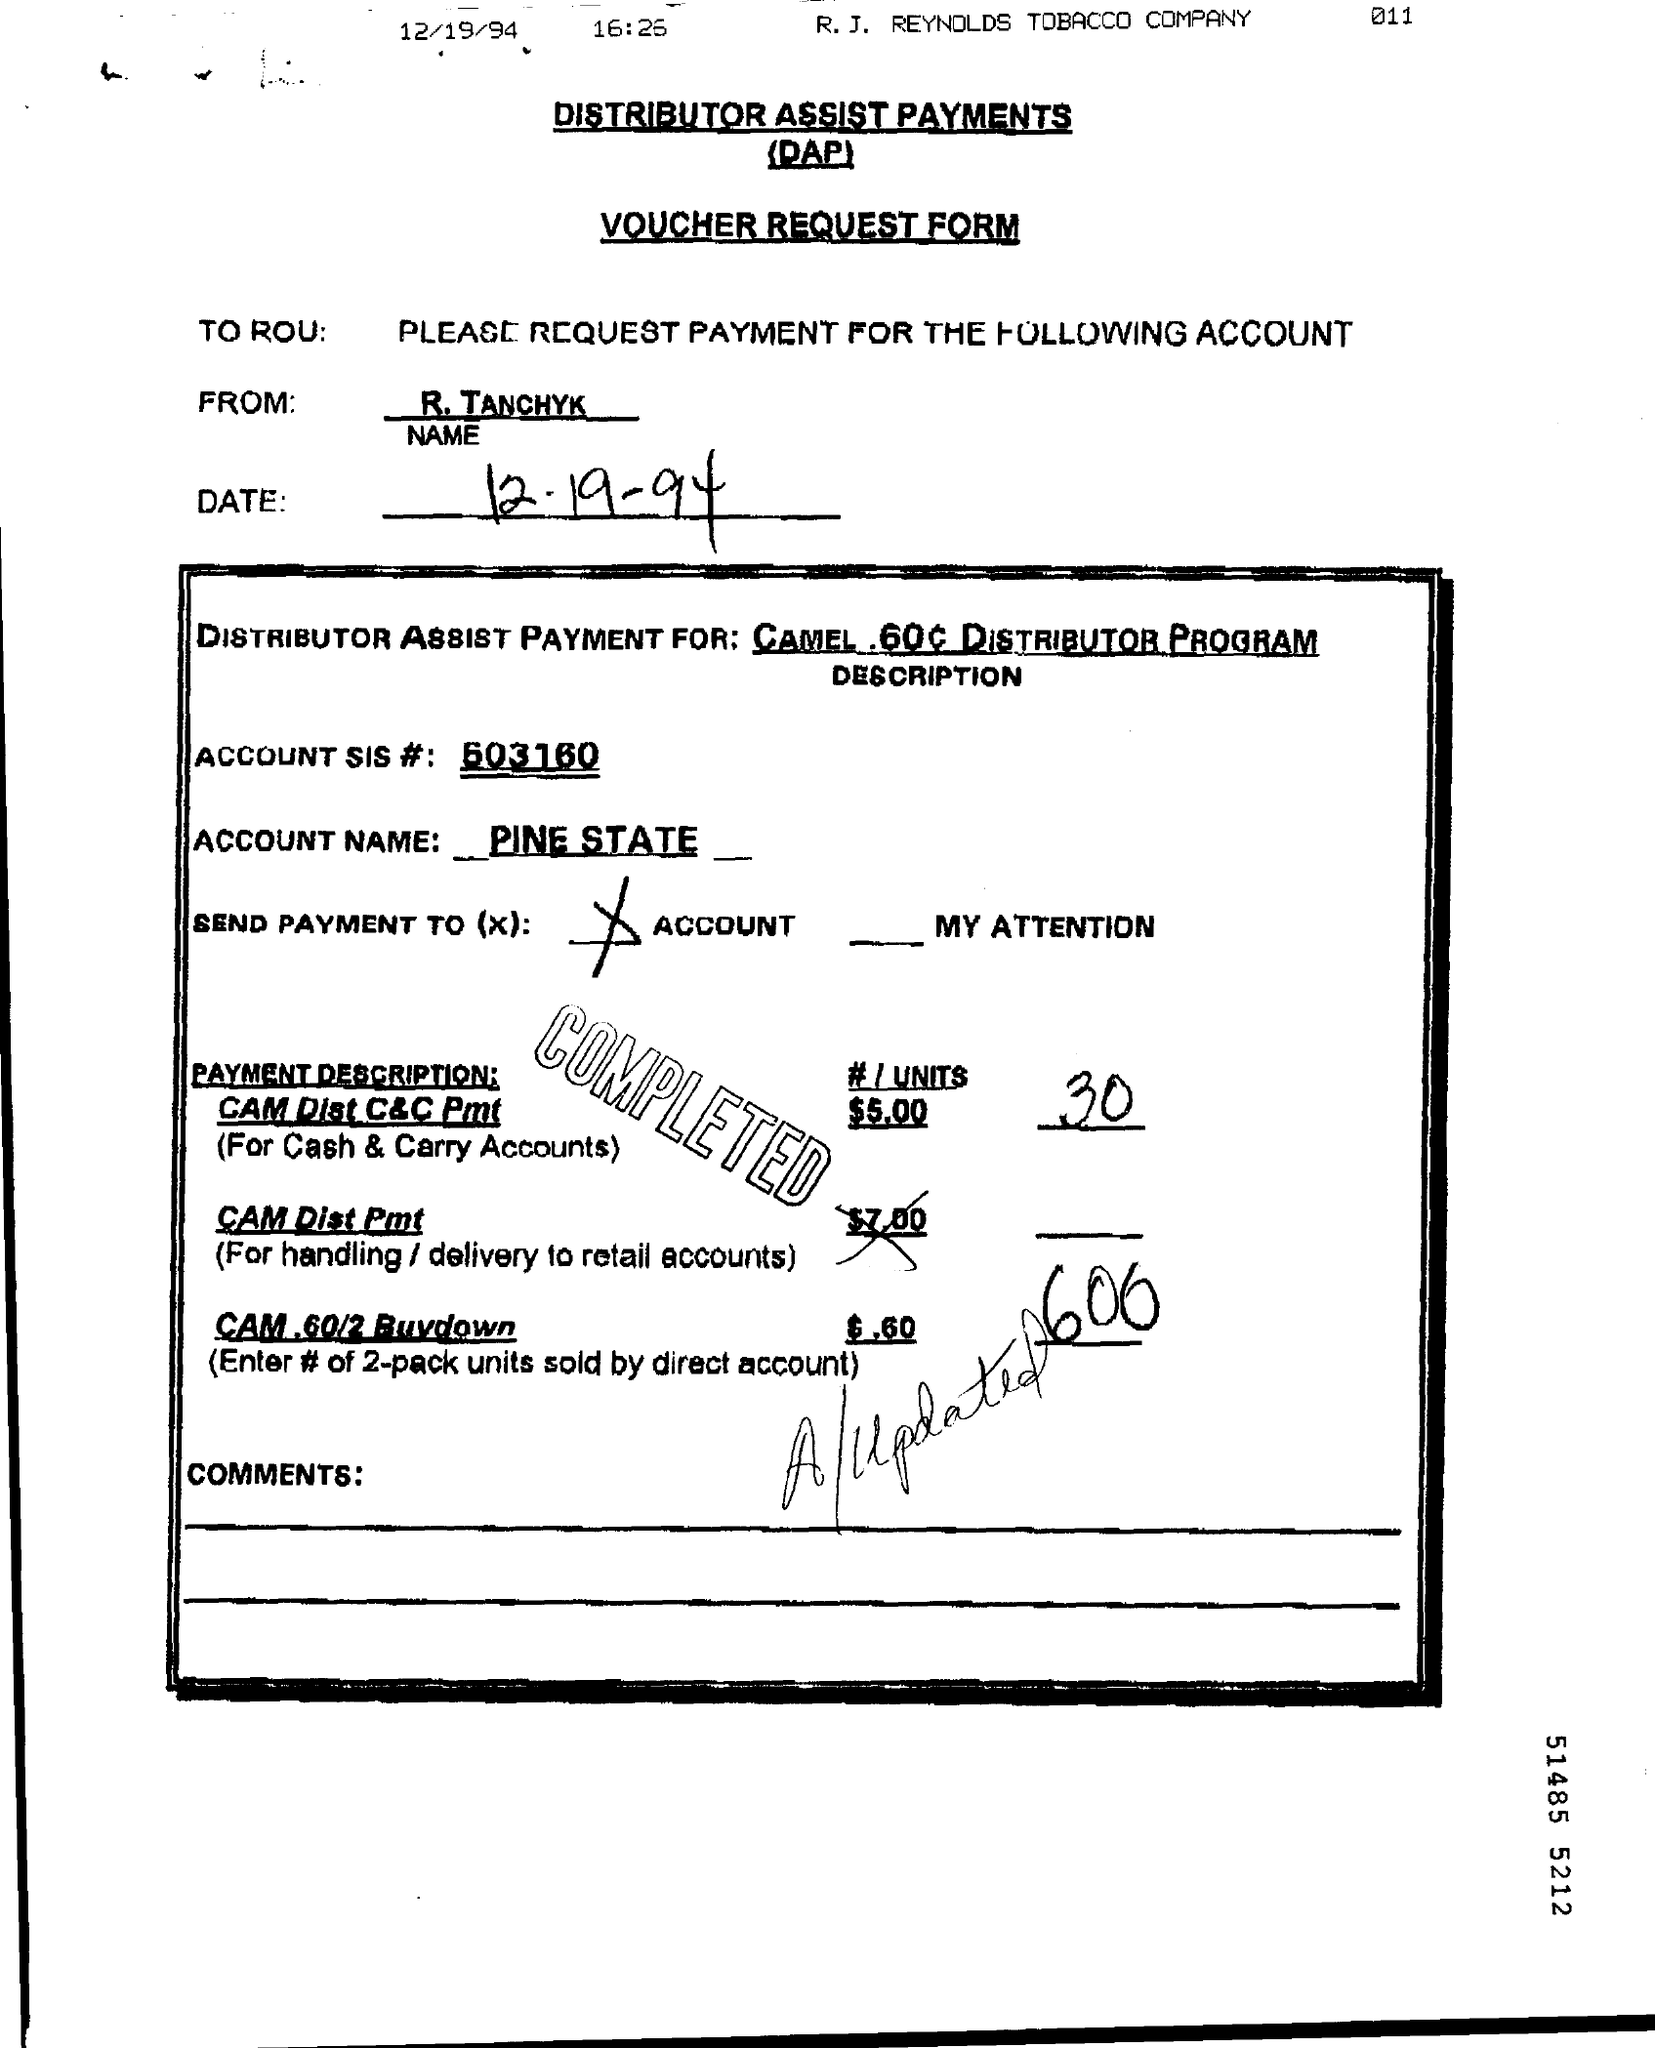Draw attention to some important aspects in this diagram. The account name is Pine State. The form being referred to is a Voucher Request Form. Distributor Assist Payments is an abbreviation for a payment made to a distributor to assist them with their work. 